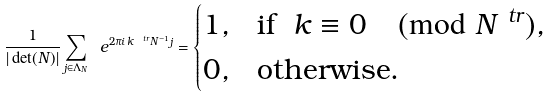<formula> <loc_0><loc_0><loc_500><loc_500>\frac { 1 } { | \det ( N ) | } \sum _ { j \in \Lambda _ { N } } \ e ^ { 2 \pi i \, k ^ { \ t r } N ^ { - 1 } j } = \begin{cases} 1 , & \text {if } \ k \equiv 0 \pmod { N ^ { \ t r } } , \\ 0 , & \text {otherwise} . \end{cases}</formula> 